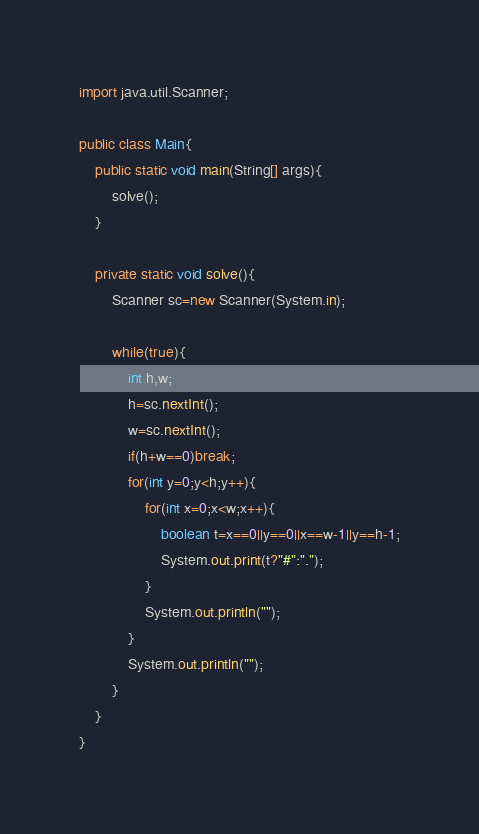<code> <loc_0><loc_0><loc_500><loc_500><_Java_>import java.util.Scanner;

public class Main{
	public static void main(String[] args){
		solve();
	}

	private static void solve(){
		Scanner sc=new Scanner(System.in);

		while(true){
			int h,w;
			h=sc.nextInt();
			w=sc.nextInt();
			if(h+w==0)break;
			for(int y=0;y<h;y++){
				for(int x=0;x<w;x++){
					boolean t=x==0||y==0||x==w-1||y==h-1;
					System.out.print(t?"#":".");
				}
				System.out.println("");
			}
			System.out.println("");
		}
	}
}</code> 